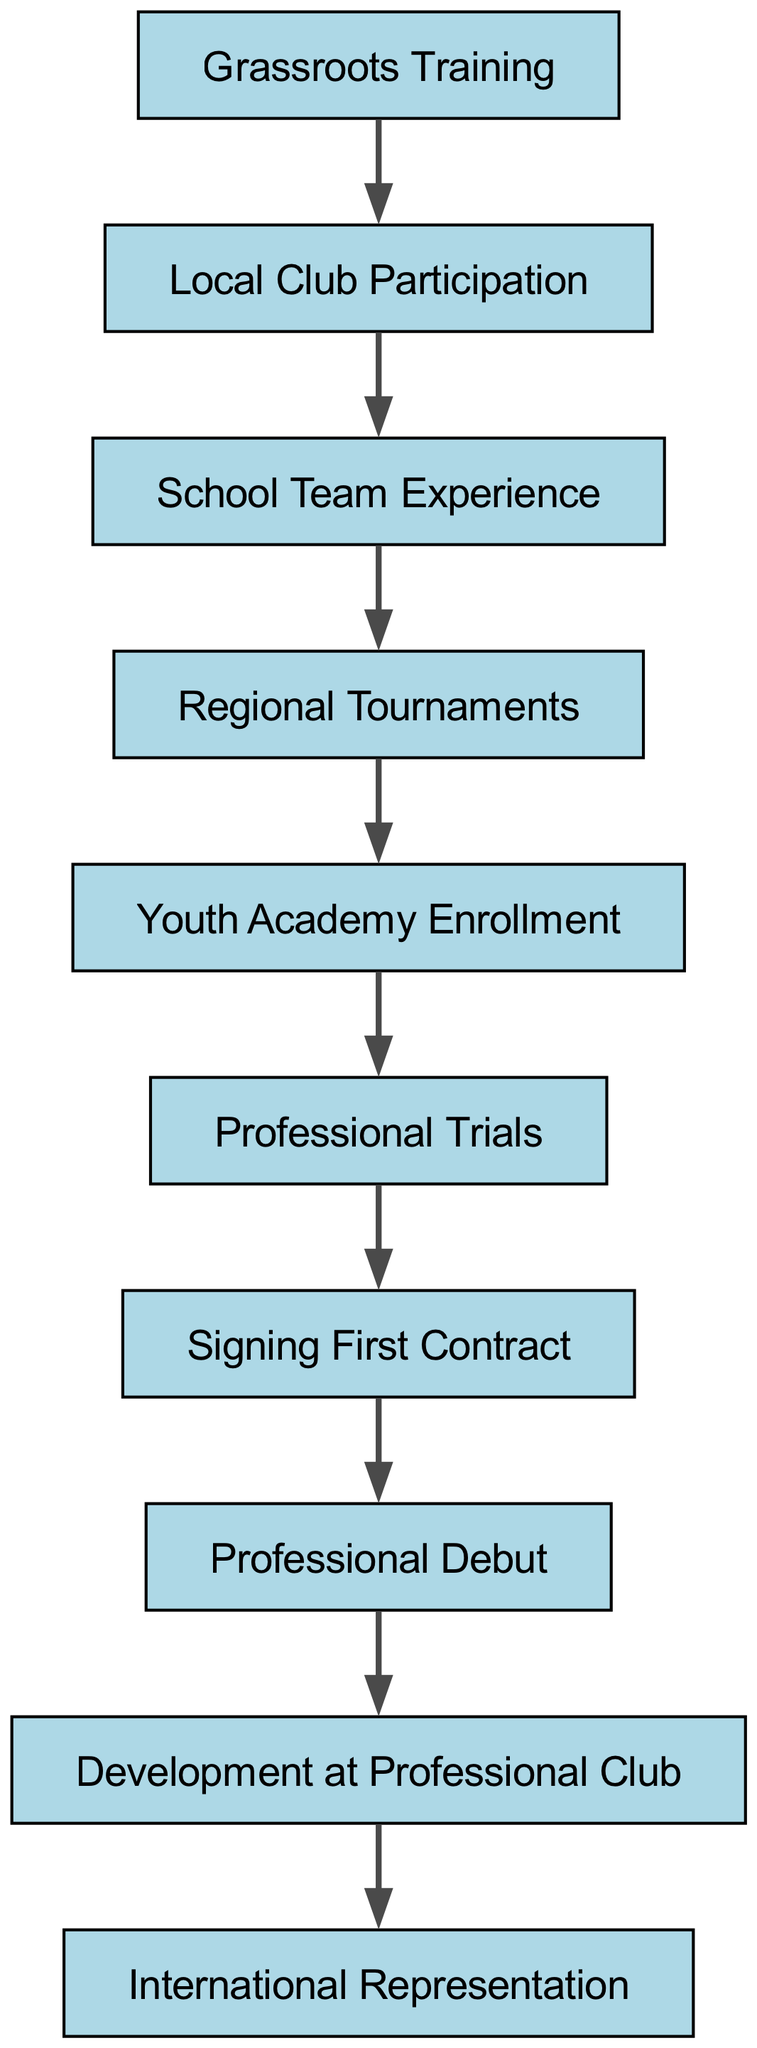What is the first milestone in the player's journey? The first milestone shown in the diagram is "Grassroots Training," which is the starting point of the pathway for a soccer player.
Answer: Grassroots Training How many nodes are in the diagram? By counting the distinct nodes listed, there are a total of 10 nodes representing key milestones in the journey from amateur to professional soccer.
Answer: 10 What milestone follows "Professional Trials"? According to the edge connecting the nodes, the milestone that follows "Professional Trials" is "Signing First Contract."
Answer: Signing First Contract What relationship does "Youth Academy Enrollment" have with "Regional Tournaments"? The relationship is that "Regional Tournaments" leads to "Youth Academy Enrollment," indicating that after participating in regional tournaments, a player can enroll in a youth academy.
Answer: Leads to How many edges are in the diagram? Counting the connections (edges) between the milestones shows there are 9 edges that indicate the flow from one milestone to another in the player's journey.
Answer: 9 What milestone is directly before "Professional Debut"? The diagram indicates that "Signing First Contract" is the milestone directly preceding "Professional Debut," showing the progression through the player's career.
Answer: Signing First Contract Which milestone is the final achievement in the player's journey? The last achievement, as represented in the diagram, is "International Representation," indicating the highest level of recognition a player can achieve.
Answer: International Representation What milestone connects "Development at Professional Club" to "International Representation"? The diagram emphasizes that "Development at Professional Club" directly leads to "International Representation," showcasing how professional growth influences international opportunities.
Answer: Leads to How does "School Team Experience" relate to "Local Club Participation"? The diagram demonstrates that "School Team Experience" follows "Local Club Participation," depicting a sequential experience for the player as they advance through their journey.
Answer: Follows 